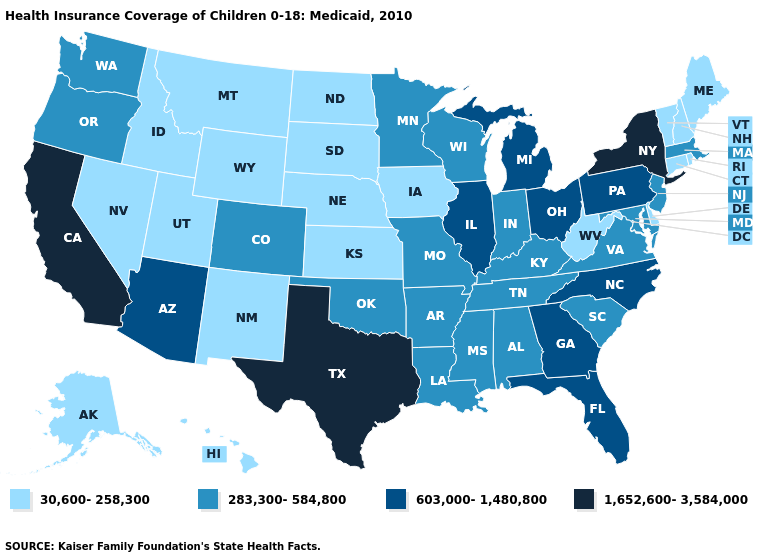Which states have the lowest value in the South?
Write a very short answer. Delaware, West Virginia. Name the states that have a value in the range 283,300-584,800?
Short answer required. Alabama, Arkansas, Colorado, Indiana, Kentucky, Louisiana, Maryland, Massachusetts, Minnesota, Mississippi, Missouri, New Jersey, Oklahoma, Oregon, South Carolina, Tennessee, Virginia, Washington, Wisconsin. What is the lowest value in states that border New Mexico?
Answer briefly. 30,600-258,300. Does Connecticut have the same value as Ohio?
Write a very short answer. No. Does the first symbol in the legend represent the smallest category?
Write a very short answer. Yes. Name the states that have a value in the range 603,000-1,480,800?
Quick response, please. Arizona, Florida, Georgia, Illinois, Michigan, North Carolina, Ohio, Pennsylvania. Does Georgia have a higher value than Arizona?
Answer briefly. No. What is the value of Maine?
Write a very short answer. 30,600-258,300. What is the value of Wyoming?
Be succinct. 30,600-258,300. Among the states that border Arkansas , which have the lowest value?
Be succinct. Louisiana, Mississippi, Missouri, Oklahoma, Tennessee. What is the value of Montana?
Concise answer only. 30,600-258,300. Among the states that border Montana , which have the highest value?
Keep it brief. Idaho, North Dakota, South Dakota, Wyoming. What is the value of New York?
Give a very brief answer. 1,652,600-3,584,000. 